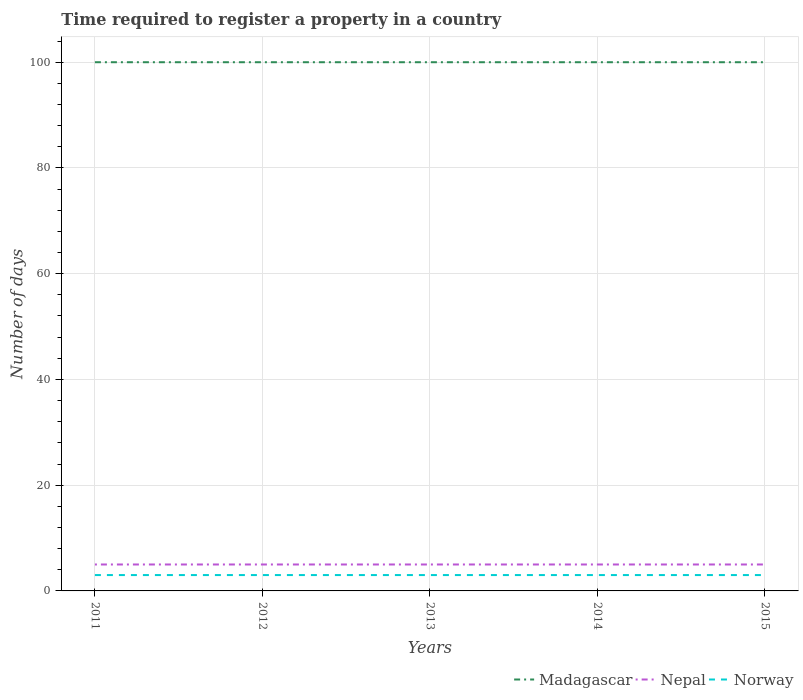How many different coloured lines are there?
Provide a succinct answer. 3. Is the number of lines equal to the number of legend labels?
Make the answer very short. Yes. Across all years, what is the maximum number of days required to register a property in Norway?
Give a very brief answer. 3. What is the difference between the highest and the second highest number of days required to register a property in Madagascar?
Offer a terse response. 0. Is the number of days required to register a property in Madagascar strictly greater than the number of days required to register a property in Nepal over the years?
Your answer should be compact. No. How many lines are there?
Give a very brief answer. 3. How many years are there in the graph?
Provide a succinct answer. 5. What is the difference between two consecutive major ticks on the Y-axis?
Provide a succinct answer. 20. How many legend labels are there?
Make the answer very short. 3. How are the legend labels stacked?
Provide a succinct answer. Horizontal. What is the title of the graph?
Keep it short and to the point. Time required to register a property in a country. Does "Moldova" appear as one of the legend labels in the graph?
Provide a short and direct response. No. What is the label or title of the X-axis?
Ensure brevity in your answer.  Years. What is the label or title of the Y-axis?
Offer a very short reply. Number of days. What is the Number of days of Nepal in 2011?
Make the answer very short. 5. What is the Number of days of Norway in 2011?
Make the answer very short. 3. What is the Number of days in Nepal in 2012?
Your answer should be compact. 5. What is the Number of days of Madagascar in 2013?
Make the answer very short. 100. What is the Number of days of Nepal in 2014?
Keep it short and to the point. 5. What is the Number of days of Madagascar in 2015?
Make the answer very short. 100. What is the Number of days in Nepal in 2015?
Keep it short and to the point. 5. Across all years, what is the maximum Number of days of Madagascar?
Your answer should be compact. 100. Across all years, what is the maximum Number of days in Nepal?
Offer a very short reply. 5. Across all years, what is the minimum Number of days of Madagascar?
Ensure brevity in your answer.  100. Across all years, what is the minimum Number of days of Nepal?
Ensure brevity in your answer.  5. Across all years, what is the minimum Number of days in Norway?
Your answer should be very brief. 3. What is the total Number of days in Norway in the graph?
Ensure brevity in your answer.  15. What is the difference between the Number of days of Nepal in 2011 and that in 2012?
Your response must be concise. 0. What is the difference between the Number of days of Norway in 2011 and that in 2012?
Give a very brief answer. 0. What is the difference between the Number of days in Norway in 2011 and that in 2013?
Your answer should be compact. 0. What is the difference between the Number of days in Madagascar in 2011 and that in 2015?
Give a very brief answer. 0. What is the difference between the Number of days of Nepal in 2011 and that in 2015?
Provide a succinct answer. 0. What is the difference between the Number of days of Norway in 2011 and that in 2015?
Make the answer very short. 0. What is the difference between the Number of days in Nepal in 2012 and that in 2013?
Provide a short and direct response. 0. What is the difference between the Number of days in Norway in 2012 and that in 2013?
Offer a very short reply. 0. What is the difference between the Number of days of Madagascar in 2012 and that in 2014?
Offer a terse response. 0. What is the difference between the Number of days of Norway in 2012 and that in 2014?
Your answer should be compact. 0. What is the difference between the Number of days in Madagascar in 2012 and that in 2015?
Make the answer very short. 0. What is the difference between the Number of days in Nepal in 2012 and that in 2015?
Provide a succinct answer. 0. What is the difference between the Number of days of Norway in 2012 and that in 2015?
Keep it short and to the point. 0. What is the difference between the Number of days of Madagascar in 2013 and that in 2014?
Your response must be concise. 0. What is the difference between the Number of days of Norway in 2013 and that in 2014?
Your answer should be compact. 0. What is the difference between the Number of days of Madagascar in 2013 and that in 2015?
Your response must be concise. 0. What is the difference between the Number of days in Nepal in 2013 and that in 2015?
Your response must be concise. 0. What is the difference between the Number of days in Norway in 2013 and that in 2015?
Provide a short and direct response. 0. What is the difference between the Number of days of Madagascar in 2014 and that in 2015?
Make the answer very short. 0. What is the difference between the Number of days in Norway in 2014 and that in 2015?
Your response must be concise. 0. What is the difference between the Number of days in Madagascar in 2011 and the Number of days in Nepal in 2012?
Provide a short and direct response. 95. What is the difference between the Number of days in Madagascar in 2011 and the Number of days in Norway in 2012?
Provide a succinct answer. 97. What is the difference between the Number of days of Nepal in 2011 and the Number of days of Norway in 2012?
Offer a terse response. 2. What is the difference between the Number of days in Madagascar in 2011 and the Number of days in Norway in 2013?
Your response must be concise. 97. What is the difference between the Number of days in Nepal in 2011 and the Number of days in Norway in 2013?
Your answer should be very brief. 2. What is the difference between the Number of days in Madagascar in 2011 and the Number of days in Norway in 2014?
Ensure brevity in your answer.  97. What is the difference between the Number of days of Madagascar in 2011 and the Number of days of Norway in 2015?
Offer a very short reply. 97. What is the difference between the Number of days in Madagascar in 2012 and the Number of days in Nepal in 2013?
Offer a terse response. 95. What is the difference between the Number of days in Madagascar in 2012 and the Number of days in Norway in 2013?
Provide a succinct answer. 97. What is the difference between the Number of days in Nepal in 2012 and the Number of days in Norway in 2013?
Keep it short and to the point. 2. What is the difference between the Number of days in Madagascar in 2012 and the Number of days in Norway in 2014?
Offer a terse response. 97. What is the difference between the Number of days of Madagascar in 2012 and the Number of days of Nepal in 2015?
Your answer should be very brief. 95. What is the difference between the Number of days of Madagascar in 2012 and the Number of days of Norway in 2015?
Ensure brevity in your answer.  97. What is the difference between the Number of days of Madagascar in 2013 and the Number of days of Nepal in 2014?
Keep it short and to the point. 95. What is the difference between the Number of days of Madagascar in 2013 and the Number of days of Norway in 2014?
Offer a terse response. 97. What is the difference between the Number of days in Madagascar in 2013 and the Number of days in Nepal in 2015?
Give a very brief answer. 95. What is the difference between the Number of days of Madagascar in 2013 and the Number of days of Norway in 2015?
Your answer should be compact. 97. What is the difference between the Number of days of Nepal in 2013 and the Number of days of Norway in 2015?
Give a very brief answer. 2. What is the difference between the Number of days in Madagascar in 2014 and the Number of days in Norway in 2015?
Keep it short and to the point. 97. What is the average Number of days of Norway per year?
Give a very brief answer. 3. In the year 2011, what is the difference between the Number of days in Madagascar and Number of days in Nepal?
Provide a short and direct response. 95. In the year 2011, what is the difference between the Number of days in Madagascar and Number of days in Norway?
Ensure brevity in your answer.  97. In the year 2011, what is the difference between the Number of days of Nepal and Number of days of Norway?
Make the answer very short. 2. In the year 2012, what is the difference between the Number of days in Madagascar and Number of days in Norway?
Your response must be concise. 97. In the year 2012, what is the difference between the Number of days in Nepal and Number of days in Norway?
Make the answer very short. 2. In the year 2013, what is the difference between the Number of days of Madagascar and Number of days of Norway?
Offer a very short reply. 97. In the year 2013, what is the difference between the Number of days in Nepal and Number of days in Norway?
Make the answer very short. 2. In the year 2014, what is the difference between the Number of days in Madagascar and Number of days in Nepal?
Provide a succinct answer. 95. In the year 2014, what is the difference between the Number of days of Madagascar and Number of days of Norway?
Your response must be concise. 97. In the year 2015, what is the difference between the Number of days in Madagascar and Number of days in Nepal?
Your response must be concise. 95. In the year 2015, what is the difference between the Number of days in Madagascar and Number of days in Norway?
Give a very brief answer. 97. In the year 2015, what is the difference between the Number of days of Nepal and Number of days of Norway?
Provide a short and direct response. 2. What is the ratio of the Number of days in Madagascar in 2011 to that in 2013?
Your answer should be very brief. 1. What is the ratio of the Number of days of Norway in 2011 to that in 2013?
Make the answer very short. 1. What is the ratio of the Number of days of Nepal in 2011 to that in 2014?
Your answer should be very brief. 1. What is the ratio of the Number of days of Norway in 2011 to that in 2014?
Your answer should be compact. 1. What is the ratio of the Number of days of Madagascar in 2011 to that in 2015?
Offer a very short reply. 1. What is the ratio of the Number of days in Nepal in 2011 to that in 2015?
Keep it short and to the point. 1. What is the ratio of the Number of days of Madagascar in 2012 to that in 2013?
Make the answer very short. 1. What is the ratio of the Number of days in Nepal in 2012 to that in 2014?
Your answer should be compact. 1. What is the ratio of the Number of days in Norway in 2012 to that in 2014?
Your answer should be compact. 1. What is the ratio of the Number of days of Madagascar in 2013 to that in 2014?
Keep it short and to the point. 1. What is the ratio of the Number of days in Nepal in 2013 to that in 2014?
Give a very brief answer. 1. What is the ratio of the Number of days of Norway in 2013 to that in 2014?
Your answer should be very brief. 1. What is the ratio of the Number of days in Nepal in 2013 to that in 2015?
Keep it short and to the point. 1. What is the ratio of the Number of days in Norway in 2013 to that in 2015?
Offer a very short reply. 1. What is the difference between the highest and the second highest Number of days in Norway?
Provide a succinct answer. 0. What is the difference between the highest and the lowest Number of days of Nepal?
Your answer should be very brief. 0. 